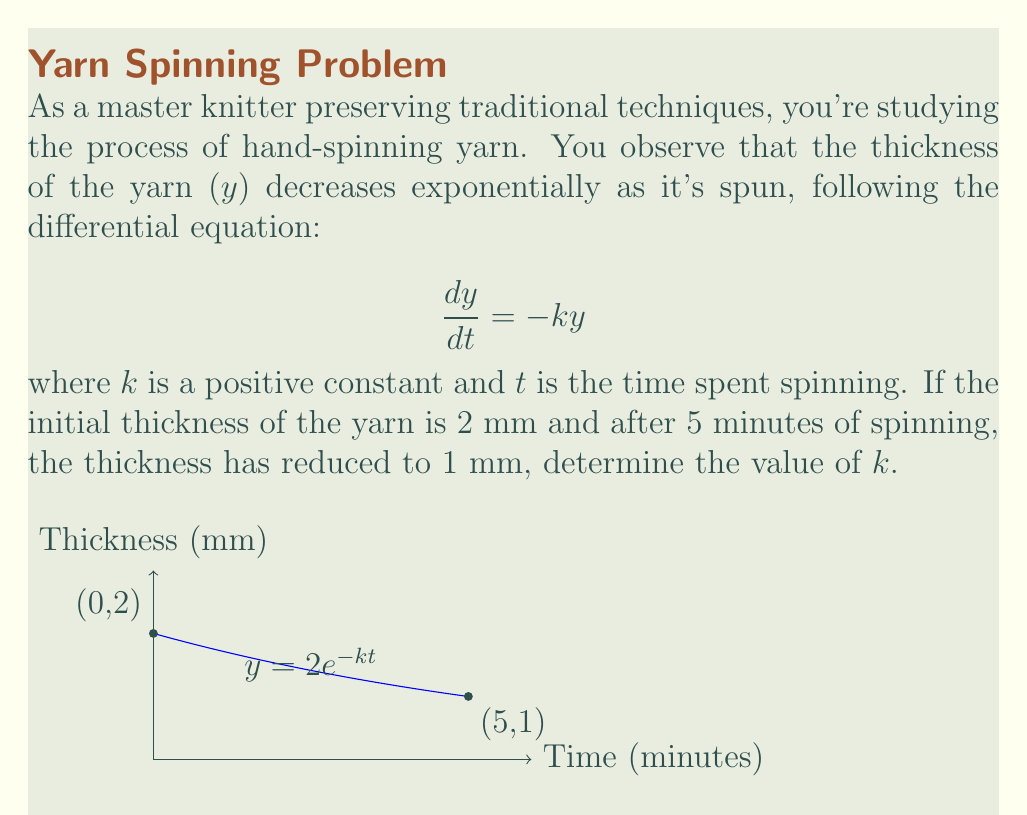Help me with this question. Let's solve this step-by-step:

1) The general solution to the differential equation $\frac{dy}{dt} = -ky$ is:

   $$y = Ce^{-kt}$$

   where $C$ is a constant determined by the initial conditions.

2) Given the initial condition that $y = 2$ when $t = 0$, we can find $C$:

   $$2 = Ce^{-k(0)} = C$$

   So our specific solution is:

   $$y = 2e^{-kt}$$

3) Now, we're told that after 5 minutes ($t = 5$), $y = 1$. Let's substitute these values:

   $$1 = 2e^{-k(5)}$$

4) Divide both sides by 2:

   $$\frac{1}{2} = e^{-5k}$$

5) Take the natural logarithm of both sides:

   $$\ln(\frac{1}{2}) = -5k$$

6) Solve for $k$:

   $$k = -\frac{\ln(\frac{1}{2})}{5} = \frac{\ln(2)}{5} \approx 0.139$$

Thus, the value of $k$ is approximately 0.139 min^(-1).
Answer: $k \approx 0.139$ min^(-1) 